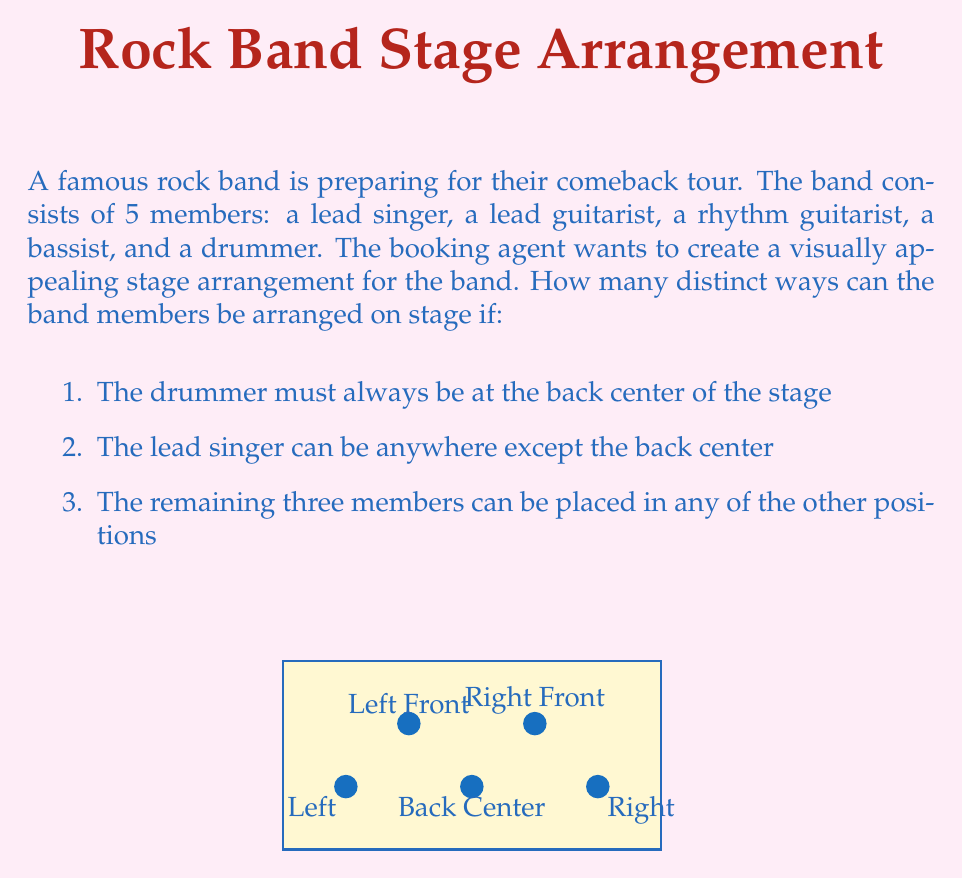What is the answer to this math problem? Let's approach this step-by-step using permutation groups:

1) First, we know the drummer is fixed at the back center. This leaves 4 positions for the other 4 members.

2) The lead singer can be in any of these 4 positions. So we have 4 choices for the lead singer.

3) After placing the lead singer, we have 3 remaining members (lead guitarist, rhythm guitarist, bassist) to arrange in the 3 remaining positions.

4) This is a straightforward permutation. The number of ways to arrange 3 members in 3 positions is $3! = 3 \times 2 \times 1 = 6$.

5) By the multiplication principle, we multiply the number of choices for each step:

   $$ \text{Total arrangements} = 4 \times 3! = 4 \times 6 = 24 $$

6) In group theory terms, this can be seen as the order of a subgroup of the symmetric group $S_5$. The subgroup is isomorphic to $S_4$, as we're essentially permuting 4 elements (with one fixed element).

Therefore, there are 24 distinct ways to arrange the band members on stage under these conditions.
Answer: 24 